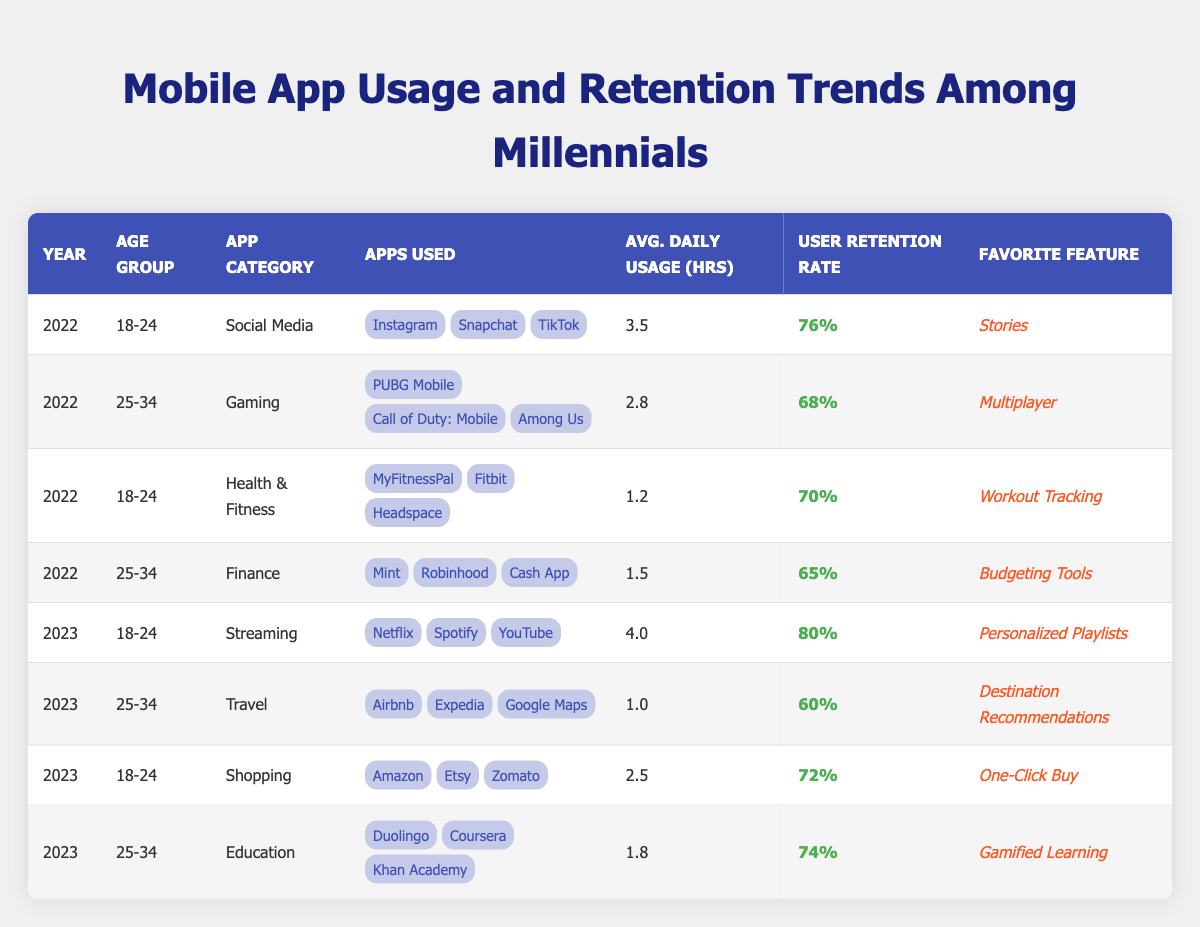What is the user retention rate for Social Media apps among 18-24 year-olds in 2022? The table shows the user retention rate for Social Media apps in 2022 for the 18-24 age group as 76%.
Answer: 76% Which app category has the highest average daily usage hours among the 18-24 age group in 2023? In 2023, for the 18-24 age group, Streaming apps have the highest average daily usage hours at 4.0 hours.
Answer: Streaming What is the favorite feature of Health & Fitness apps for the 18-24 age group in 2022? According to the table, the favorite feature for Health & Fitness apps among the 18-24 age group in 2022 is "Workout Tracking".
Answer: Workout Tracking Is the user retention rate for Education apps among 25-34 year-olds in 2023 greater than 70%? The retention rate for Education apps in 2023 for the 25-34 age group is 74%, which is indeed greater than 70%.
Answer: Yes What is the difference in average daily usage hours between Gaming and Finance apps for the 25-34 age group in 2022? For the 25-34 age group in 2022, Gaming apps have an average daily usage of 2.8 hours, while Finance apps have 1.5 hours. The difference is 2.8 - 1.5 = 1.3 hours.
Answer: 1.3 hours Which age group shows a higher user retention rate for Social Media apps, 18-24 or 25-34 in 2022? The user retention rate for 18-24 year-olds in Social Media apps is 76% and for 25-34 year-olds is 68%. Since 76% is greater than 68%, the 18-24 age group shows a higher retention rate.
Answer: 18-24 What average daily usage hours do Shopping apps have for the 18-24 age group in 2023, and how does it compare to Health & Fitness apps for the same age group in 2022? The average daily usage hours for Shopping apps in 2023 for the 18-24 age group is 2.5 hours, while Health & Fitness apps in 2022 had 1.2 hours. The Shopping apps usage is greater by 2.5 - 1.2 = 1.3 hours.
Answer: 1.3 hours In 2023, what is the favorite feature of the Streaming app category for the 18-24 age group? The table indicates that the favorite feature for the Streaming app category among the 18-24 age group in 2023 is "Personalized Playlists".
Answer: Personalized Playlists Has the average daily usage hours for Travel apps among 25-34 year-olds increased from 2022 to 2023? In 2022, there is no data for Travel apps in the previous year for the 25-34 age group, and the average is 1.0 in 2023. Hence, we cannot determine any comparison.
Answer: No data for 2022 What is the average user retention rate across all age groups for the Gaming app category in 2022? For the Gaming app category in 2022, the user retention rate for the 25-34 age group is 68%. As there is no data for 18-24, the average is just 68%.
Answer: 68% 